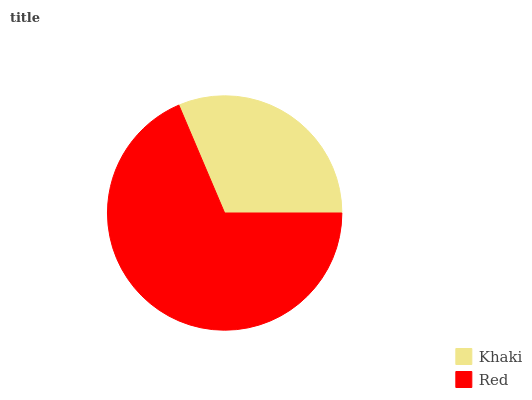Is Khaki the minimum?
Answer yes or no. Yes. Is Red the maximum?
Answer yes or no. Yes. Is Red the minimum?
Answer yes or no. No. Is Red greater than Khaki?
Answer yes or no. Yes. Is Khaki less than Red?
Answer yes or no. Yes. Is Khaki greater than Red?
Answer yes or no. No. Is Red less than Khaki?
Answer yes or no. No. Is Red the high median?
Answer yes or no. Yes. Is Khaki the low median?
Answer yes or no. Yes. Is Khaki the high median?
Answer yes or no. No. Is Red the low median?
Answer yes or no. No. 